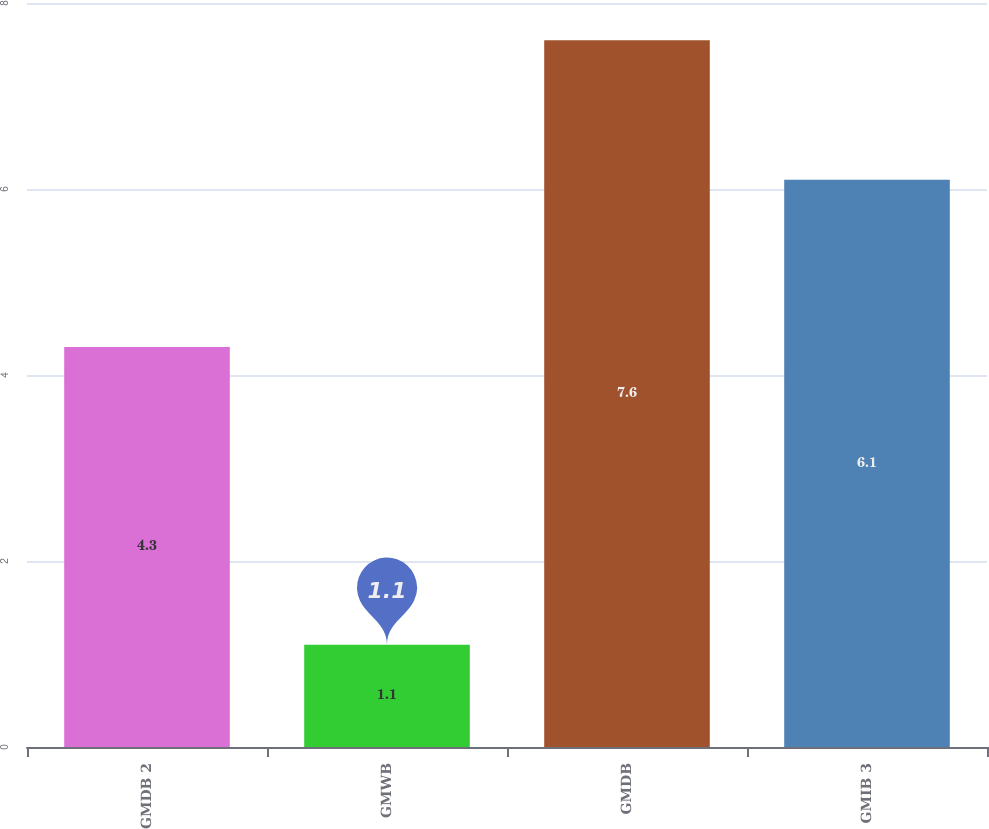<chart> <loc_0><loc_0><loc_500><loc_500><bar_chart><fcel>GMDB 2<fcel>GMWB<fcel>GMDB<fcel>GMIB 3<nl><fcel>4.3<fcel>1.1<fcel>7.6<fcel>6.1<nl></chart> 